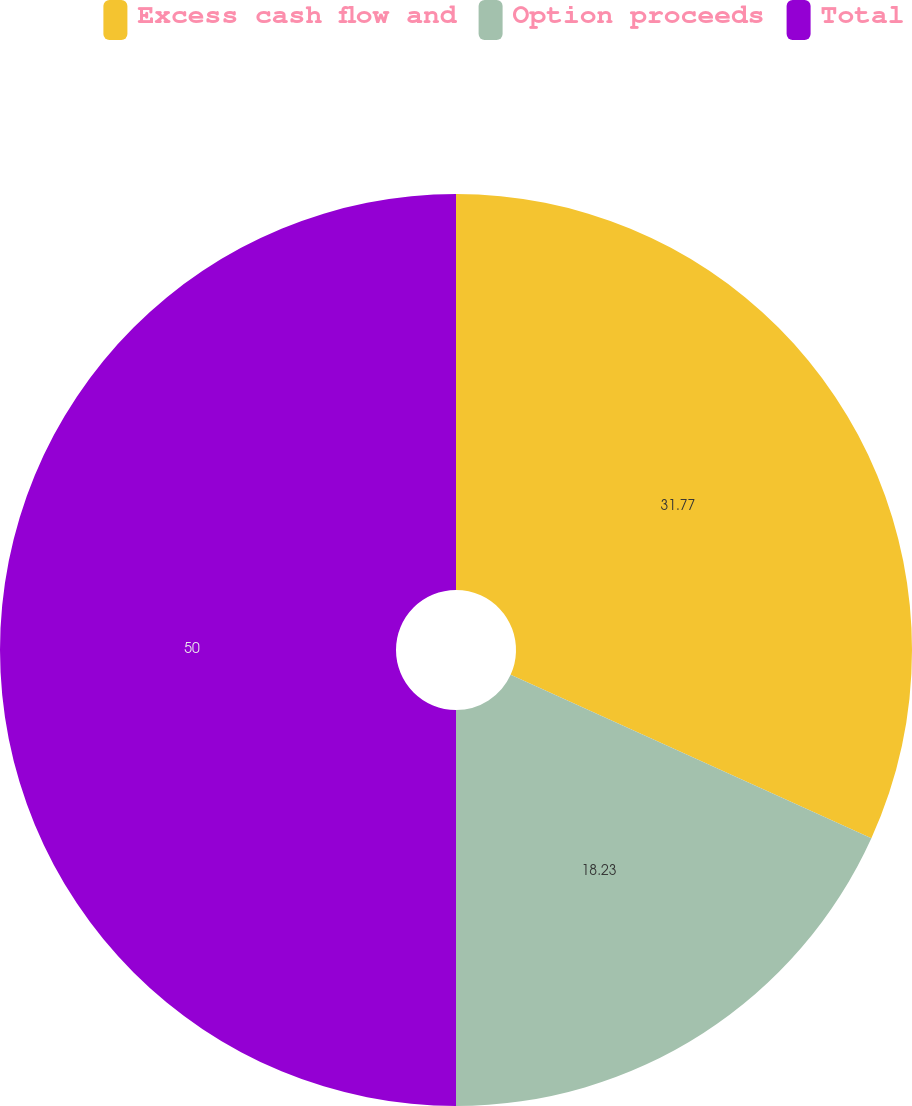Convert chart to OTSL. <chart><loc_0><loc_0><loc_500><loc_500><pie_chart><fcel>Excess cash flow and<fcel>Option proceeds<fcel>Total<nl><fcel>31.77%<fcel>18.23%<fcel>50.0%<nl></chart> 